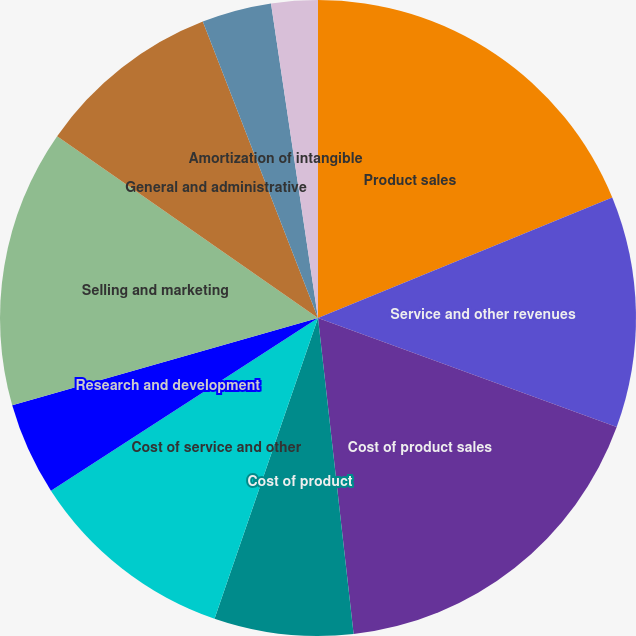Convert chart to OTSL. <chart><loc_0><loc_0><loc_500><loc_500><pie_chart><fcel>Product sales<fcel>Service and other revenues<fcel>Cost of product sales<fcel>Cost of product<fcel>Cost of service and other<fcel>Research and development<fcel>Selling and marketing<fcel>General and administrative<fcel>Amortization of intangible<fcel>Restructuring and divestiture<nl><fcel>18.81%<fcel>11.76%<fcel>17.64%<fcel>7.06%<fcel>10.59%<fcel>4.71%<fcel>14.11%<fcel>9.41%<fcel>3.54%<fcel>2.36%<nl></chart> 